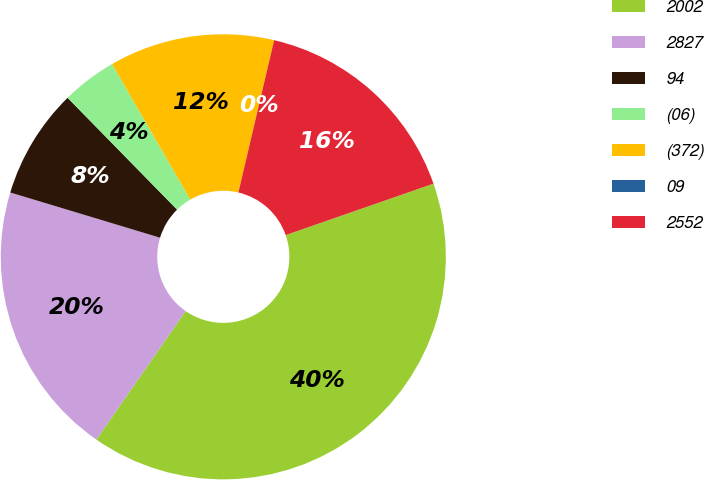Convert chart. <chart><loc_0><loc_0><loc_500><loc_500><pie_chart><fcel>2002<fcel>2827<fcel>94<fcel>(06)<fcel>(372)<fcel>09<fcel>2552<nl><fcel>39.99%<fcel>20.0%<fcel>8.0%<fcel>4.0%<fcel>12.0%<fcel>0.0%<fcel>16.0%<nl></chart> 